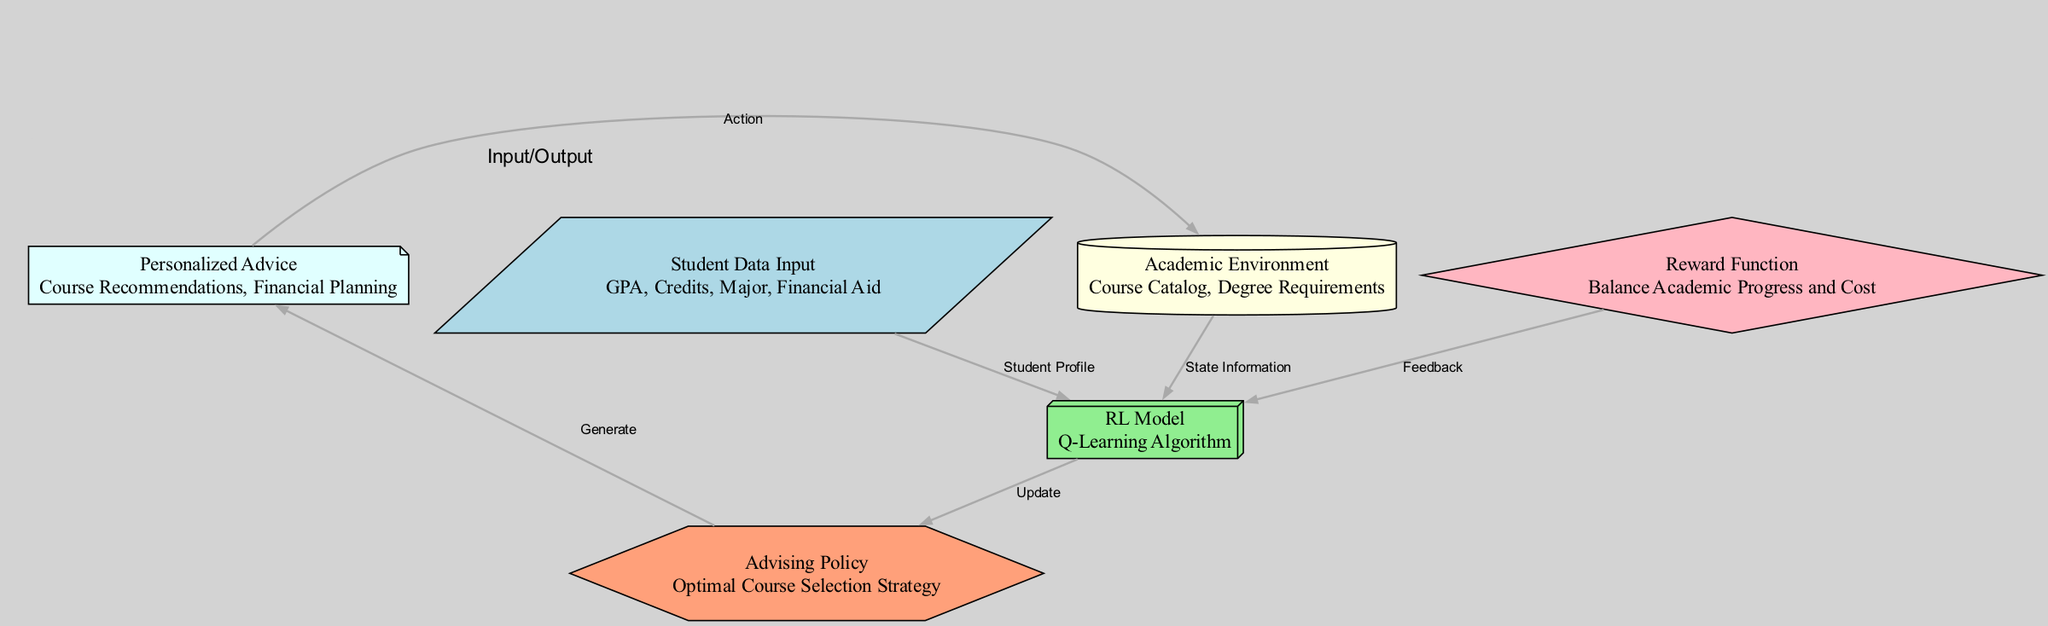What are the rewards based on? The reward function is designed to balance academic progress and cost, indicating that it considers both educational goals and financial constraints.
Answer: Balance Academic Progress and Cost How many nodes are in the diagram? The diagram contains six nodes: Student Data Input, RL Model, Academic Environment, Reward Function, Advising Policy, and Personalized Advice.
Answer: Six What is the role of the RL Model? The RL Model employs a Q-Learning algorithm to analyze the student data and the academic environment to make updates to the advising policy.
Answer: Q-Learning Algorithm Which node generates personalized advice? The output node, labeled Personalized Advice, is responsible for generating course recommendations and financial planning for students.
Answer: Personalized Advice What flows into the RL Model from the Reward Function? The feedback from the Reward Function flows into the RL Model, providing it with direction for adjustments in its learning process.
Answer: Feedback What does the Advising Policy node produce? The Advising Policy node generates the optimal course selection strategy based on the insights provided by the RL Model.
Answer: Optimal Course Selection Strategy What is the first step of the advising process? The first step is the Student Data Input, where information such as GPA, Credits, Major, and Financial Aid is collected.
Answer: Student Data Input Which edge connects the output to the environment? The edge labeled Action connects the output node to the environment, indicating that the personalized advice influences the academic environment.
Answer: Action What connects the Academic Environment to the RL Model? State Information connects the Academic Environment to the RL Model, as it provides necessary context for the model's decision-making.
Answer: State Information 